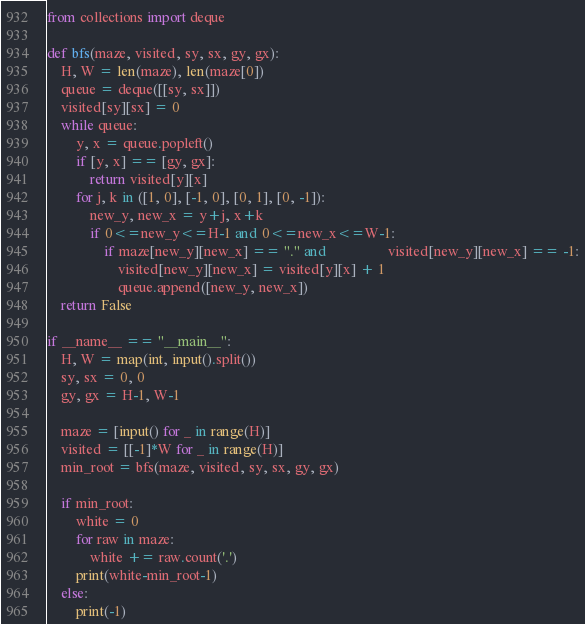Convert code to text. <code><loc_0><loc_0><loc_500><loc_500><_Python_>from collections import deque

def bfs(maze, visited, sy, sx, gy, gx):
    H, W = len(maze), len(maze[0])
    queue = deque([[sy, sx]])
    visited[sy][sx] = 0
    while queue:
        y, x = queue.popleft()
        if [y, x] == [gy, gx]:
            return visited[y][x]
        for j, k in ([1, 0], [-1, 0], [0, 1], [0, -1]):
            new_y, new_x = y+j, x+k
            if 0<=new_y<=H-1 and 0<=new_x<=W-1:
                if maze[new_y][new_x] == "." and                 visited[new_y][new_x] == -1:
                    visited[new_y][new_x] = visited[y][x] + 1
                    queue.append([new_y, new_x])
    return False

if __name__ == "__main__":
    H, W = map(int, input().split())
    sy, sx = 0, 0
    gy, gx = H-1, W-1

    maze = [input() for _ in range(H)]
    visited = [[-1]*W for _ in range(H)]
    min_root = bfs(maze, visited, sy, sx, gy, gx)
    
    if min_root:
    	white = 0
    	for raw in maze:
    		white += raw.count('.')
    	print(white-min_root-1)
    else:
    	print(-1)</code> 